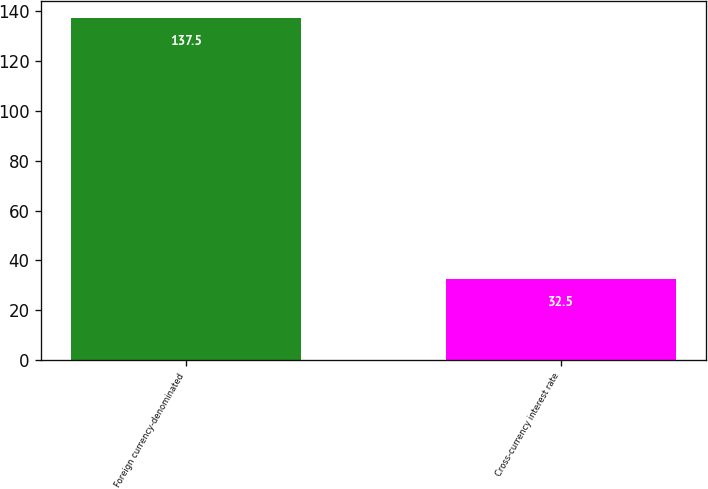<chart> <loc_0><loc_0><loc_500><loc_500><bar_chart><fcel>Foreign currency-denominated<fcel>Cross-currency interest rate<nl><fcel>137.5<fcel>32.5<nl></chart> 